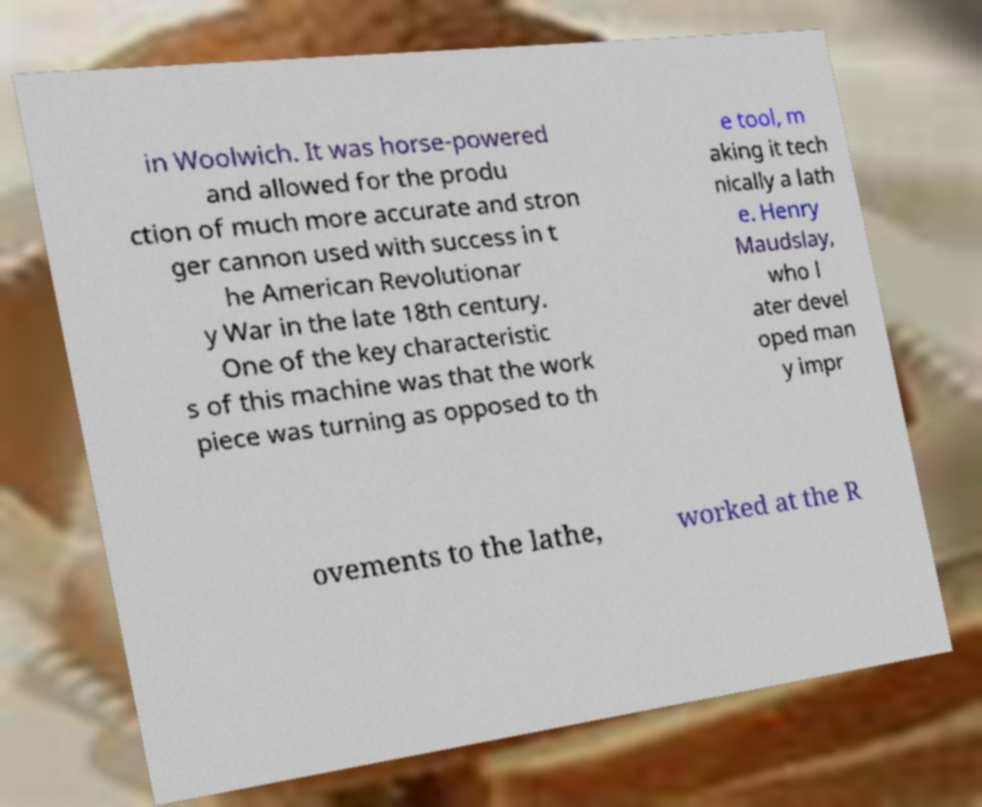There's text embedded in this image that I need extracted. Can you transcribe it verbatim? in Woolwich. It was horse-powered and allowed for the produ ction of much more accurate and stron ger cannon used with success in t he American Revolutionar y War in the late 18th century. One of the key characteristic s of this machine was that the work piece was turning as opposed to th e tool, m aking it tech nically a lath e. Henry Maudslay, who l ater devel oped man y impr ovements to the lathe, worked at the R 